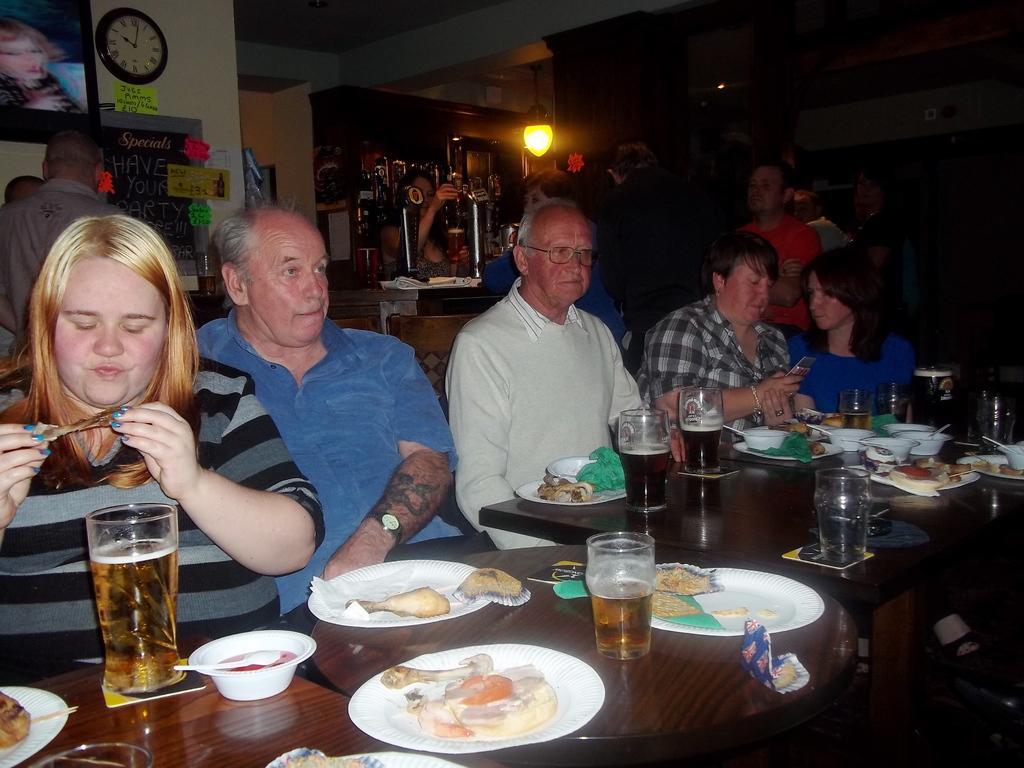Describe this image in one or two sentences. In this image I can see number of people were few are standing and rest are sitting on chairs. on this tablet I can see few glasses and food in plates. In the background I can see a light and few posters, a clock on this wall. 